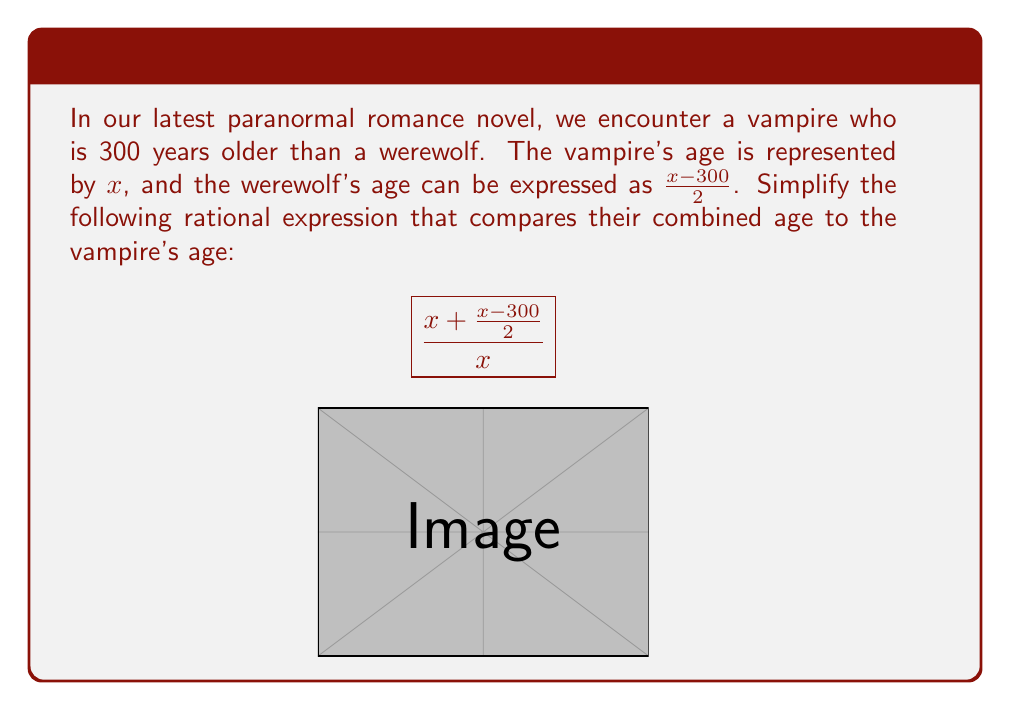Give your solution to this math problem. Let's simplify this rational expression step-by-step:

1) First, let's simplify the numerator by finding a common denominator:
   $$\frac{2x + (x-300)}{2}$$

2) Expand the numerator:
   $$\frac{2x + x - 300}{2} = \frac{3x - 300}{2}$$

3) Now our expression looks like this:
   $$\frac{\frac{3x - 300}{2}}{x}$$

4) To divide fractions, we multiply by the reciprocal:
   $$\frac{\frac{3x - 300}{2}}{x} = \frac{3x - 300}{2} \cdot \frac{1}{x}$$

5) Multiply the numerators and denominators:
   $$\frac{3x - 300}{2x}$$

6) This is our simplified rational expression. We can't reduce further as there are no common factors between the numerator and denominator.
Answer: $$\frac{3x - 300}{2x}$$ 